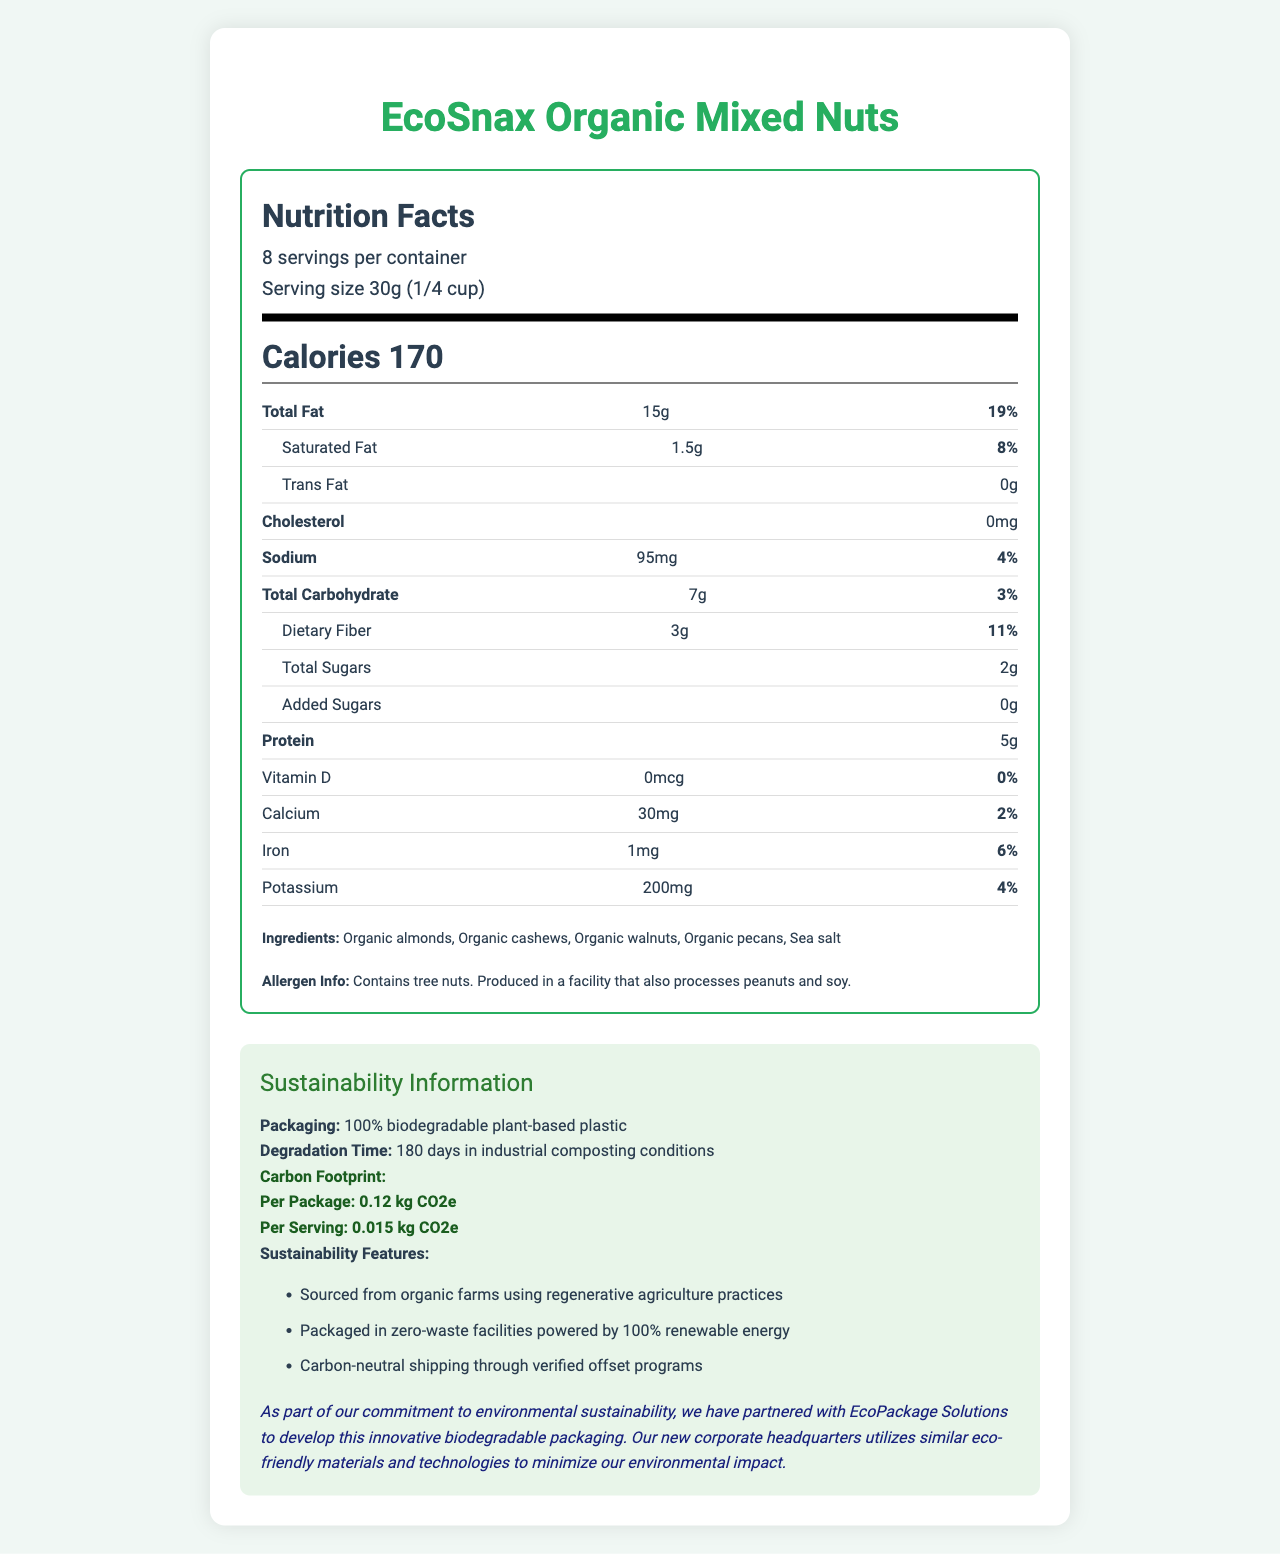What is the serving size of EcoSnax Organic Mixed Nuts? The serving size is mentioned at the top of the nutrition label under the title "Serving size."
Answer: 30g (1/4 cup) How many servings are there per container? The number of servings per container is listed directly above the serving size information.
Answer: 8 What is the total fat content per serving? The total fat content per serving is shown on the nutrition label under "Total Fat."
Answer: 15g How many grams of protein are in one serving? The protein content is listed in the nutrition facts section under "Protein."
Answer: 5g What is the carbon footprint per package of EcoSnax Organic Mixed Nuts? The carbon footprint per package is in the sustainability information section under "Carbon Footprint."
Answer: 0.12 kg CO2e How long does the biodegradable packaging take to degrade in industrial composting conditions? A. 90 days B. 120 days C. 150 days D. 180 days The degradation time is mentioned under the packaging information in the sustainability section as "180 days in industrial composting conditions."
Answer: D Which nutrient has the highest daily value percentage? A. Total Fat B. Dietary Fiber C. Sodium D. Iron Total Fat has the highest daily value percentage of 19%, which is higher than Sodium (4%), Dietary Fiber (11%), and Iron (6%).
Answer: A Does the product contain added sugars? The nutrition facts label shows added sugars as "0g."
Answer: No Does EcoSnax Organic Mixed Nuts contain any allergens? The allergen information states that the product contains tree nuts and is produced in a facility that processes peanuts and soy.
Answer: Yes Summarize the main sustainability commitments of the company related to this product. The information about the company's sustainability commitments is provided in the sustainability section and under the company commitment statement.
Answer: The company uses 100% biodegradable plant-based plastic for packaging, sources ingredients from organic farms using regenerative agriculture practices, operates zero-waste facilities powered by renewable energy, and ensures carbon-neutral shipping through offset programs. What is the product's sodium content per serving? The sodium content per serving is provided in the nutrition facts section under "Sodium."
Answer: 95mg What percentage of daily value does saturated fat contribute? The daily value percentage for saturated fat is listed in the nutrition facts under "Saturated Fat."
Answer: 8% Identify one ingredient in the product. The ingredients list features "Organic almonds" as one of the ingredients.
Answer: Organic almonds What is the source of renewable energy mentioned in the document? The document states that the packaging is done in zero-waste facilities powered by 100% renewable energy, but it does not specify the exact source of that renewable energy (e.g., solar, wind).
Answer: Not enough information 